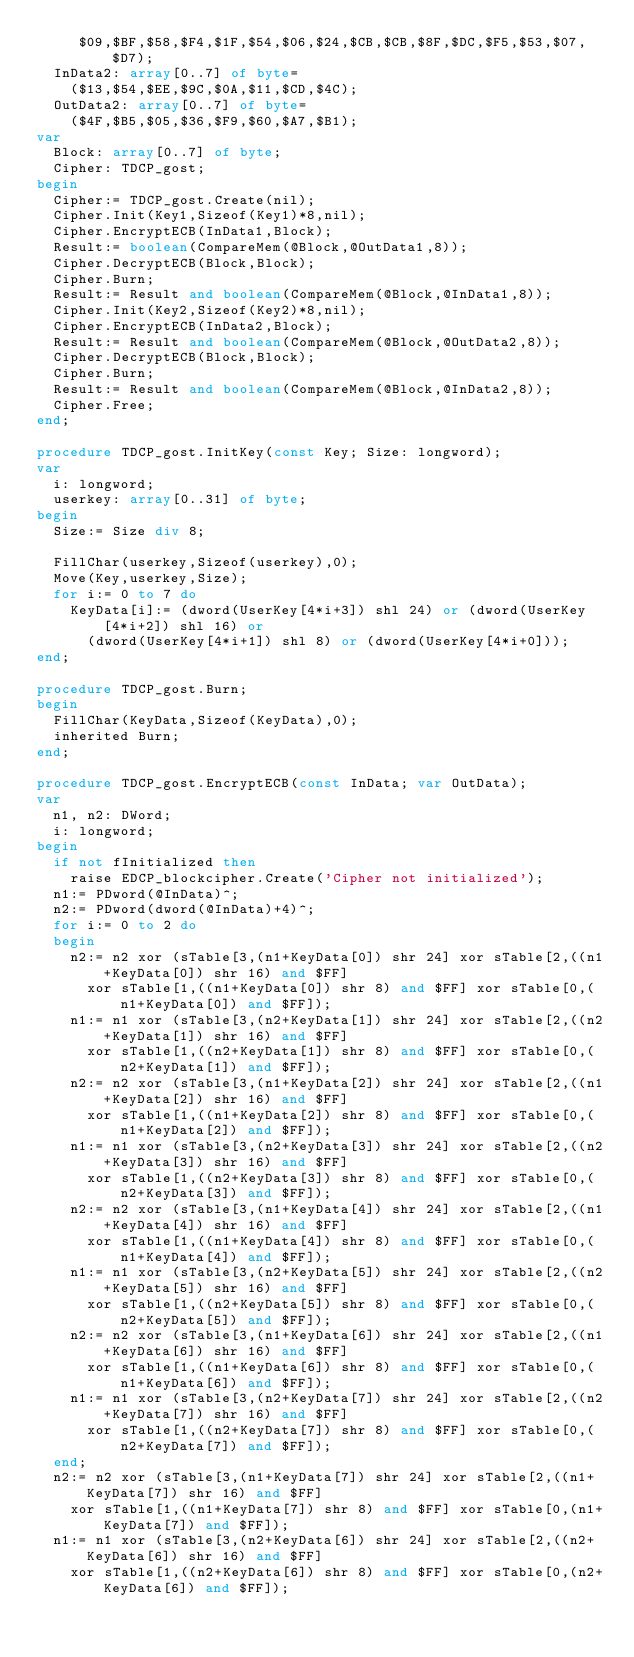Convert code to text. <code><loc_0><loc_0><loc_500><loc_500><_Pascal_>     $09,$BF,$58,$F4,$1F,$54,$06,$24,$CB,$CB,$8F,$DC,$F5,$53,$07,$D7);
  InData2: array[0..7] of byte=
    ($13,$54,$EE,$9C,$0A,$11,$CD,$4C);
  OutData2: array[0..7] of byte=
    ($4F,$B5,$05,$36,$F9,$60,$A7,$B1);
var
  Block: array[0..7] of byte;
  Cipher: TDCP_gost;
begin
  Cipher:= TDCP_gost.Create(nil);
  Cipher.Init(Key1,Sizeof(Key1)*8,nil);
  Cipher.EncryptECB(InData1,Block);
  Result:= boolean(CompareMem(@Block,@OutData1,8));
  Cipher.DecryptECB(Block,Block);
  Cipher.Burn;
  Result:= Result and boolean(CompareMem(@Block,@InData1,8));
  Cipher.Init(Key2,Sizeof(Key2)*8,nil);
  Cipher.EncryptECB(InData2,Block);
  Result:= Result and boolean(CompareMem(@Block,@OutData2,8));
  Cipher.DecryptECB(Block,Block);
  Cipher.Burn;
  Result:= Result and boolean(CompareMem(@Block,@InData2,8));
  Cipher.Free;
end;

procedure TDCP_gost.InitKey(const Key; Size: longword);
var
  i: longword;
  userkey: array[0..31] of byte;
begin
  Size:= Size div 8;

  FillChar(userkey,Sizeof(userkey),0);
  Move(Key,userkey,Size);
  for i:= 0 to 7 do
    KeyData[i]:= (dword(UserKey[4*i+3]) shl 24) or (dword(UserKey[4*i+2]) shl 16) or
      (dword(UserKey[4*i+1]) shl 8) or (dword(UserKey[4*i+0]));
end;

procedure TDCP_gost.Burn;
begin
  FillChar(KeyData,Sizeof(KeyData),0);
  inherited Burn;
end;

procedure TDCP_gost.EncryptECB(const InData; var OutData);
var
  n1, n2: DWord;
  i: longword;
begin
  if not fInitialized then
    raise EDCP_blockcipher.Create('Cipher not initialized');
  n1:= PDword(@InData)^;
  n2:= PDword(dword(@InData)+4)^;
  for i:= 0 to 2 do
  begin
    n2:= n2 xor (sTable[3,(n1+KeyData[0]) shr 24] xor sTable[2,((n1+KeyData[0]) shr 16) and $FF]
      xor sTable[1,((n1+KeyData[0]) shr 8) and $FF] xor sTable[0,(n1+KeyData[0]) and $FF]);
    n1:= n1 xor (sTable[3,(n2+KeyData[1]) shr 24] xor sTable[2,((n2+KeyData[1]) shr 16) and $FF]
      xor sTable[1,((n2+KeyData[1]) shr 8) and $FF] xor sTable[0,(n2+KeyData[1]) and $FF]);
    n2:= n2 xor (sTable[3,(n1+KeyData[2]) shr 24] xor sTable[2,((n1+KeyData[2]) shr 16) and $FF]
      xor sTable[1,((n1+KeyData[2]) shr 8) and $FF] xor sTable[0,(n1+KeyData[2]) and $FF]);
    n1:= n1 xor (sTable[3,(n2+KeyData[3]) shr 24] xor sTable[2,((n2+KeyData[3]) shr 16) and $FF]
      xor sTable[1,((n2+KeyData[3]) shr 8) and $FF] xor sTable[0,(n2+KeyData[3]) and $FF]);
    n2:= n2 xor (sTable[3,(n1+KeyData[4]) shr 24] xor sTable[2,((n1+KeyData[4]) shr 16) and $FF]
      xor sTable[1,((n1+KeyData[4]) shr 8) and $FF] xor sTable[0,(n1+KeyData[4]) and $FF]);
    n1:= n1 xor (sTable[3,(n2+KeyData[5]) shr 24] xor sTable[2,((n2+KeyData[5]) shr 16) and $FF]
      xor sTable[1,((n2+KeyData[5]) shr 8) and $FF] xor sTable[0,(n2+KeyData[5]) and $FF]);
    n2:= n2 xor (sTable[3,(n1+KeyData[6]) shr 24] xor sTable[2,((n1+KeyData[6]) shr 16) and $FF]
      xor sTable[1,((n1+KeyData[6]) shr 8) and $FF] xor sTable[0,(n1+KeyData[6]) and $FF]);
    n1:= n1 xor (sTable[3,(n2+KeyData[7]) shr 24] xor sTable[2,((n2+KeyData[7]) shr 16) and $FF]
      xor sTable[1,((n2+KeyData[7]) shr 8) and $FF] xor sTable[0,(n2+KeyData[7]) and $FF]);
  end;
  n2:= n2 xor (sTable[3,(n1+KeyData[7]) shr 24] xor sTable[2,((n1+KeyData[7]) shr 16) and $FF]
    xor sTable[1,((n1+KeyData[7]) shr 8) and $FF] xor sTable[0,(n1+KeyData[7]) and $FF]);
  n1:= n1 xor (sTable[3,(n2+KeyData[6]) shr 24] xor sTable[2,((n2+KeyData[6]) shr 16) and $FF]
    xor sTable[1,((n2+KeyData[6]) shr 8) and $FF] xor sTable[0,(n2+KeyData[6]) and $FF]);</code> 